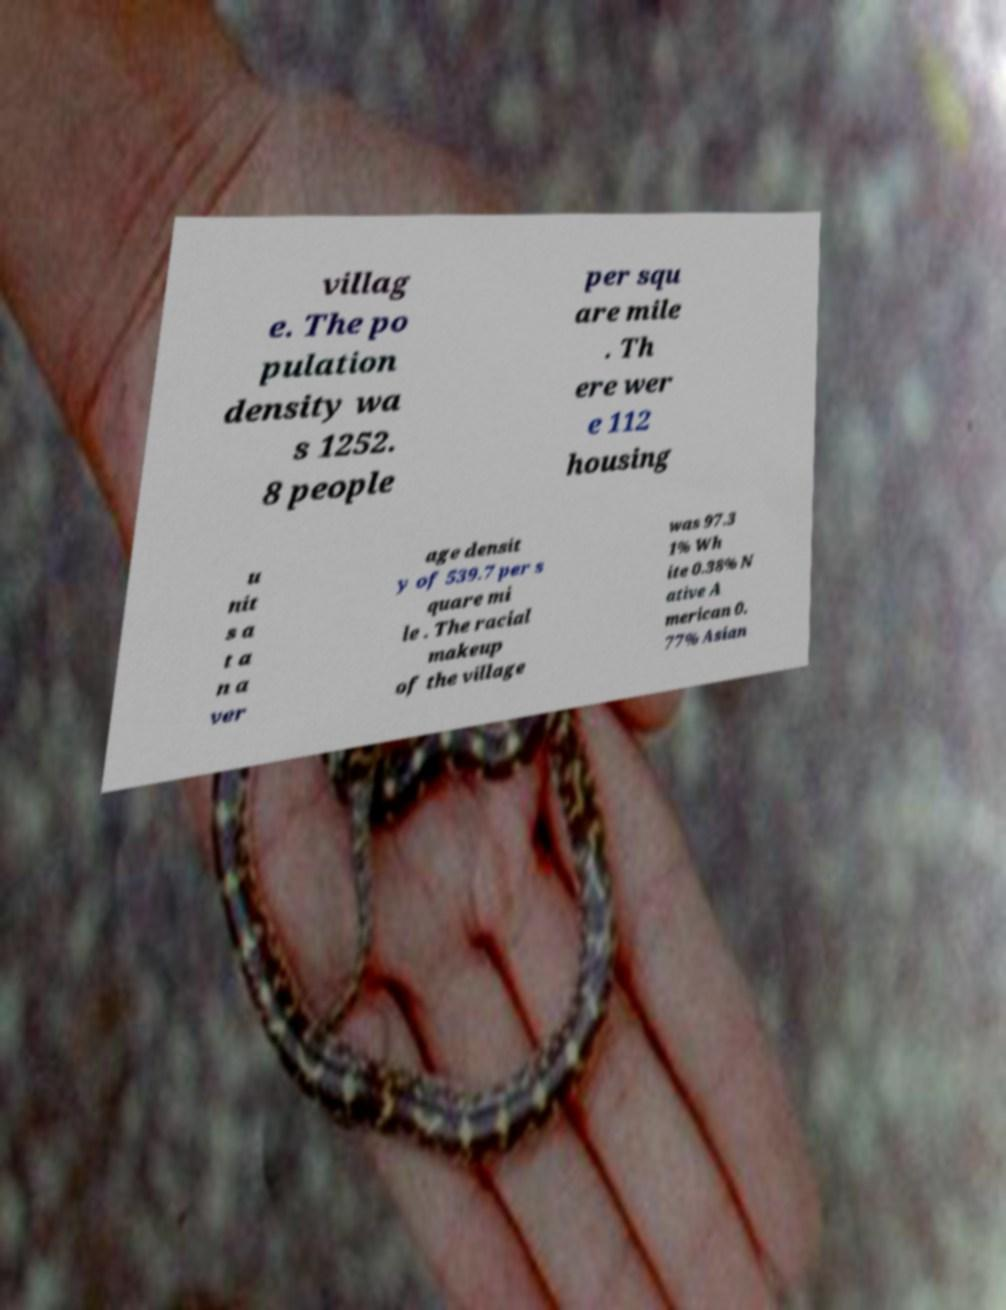Could you extract and type out the text from this image? villag e. The po pulation density wa s 1252. 8 people per squ are mile . Th ere wer e 112 housing u nit s a t a n a ver age densit y of 539.7 per s quare mi le . The racial makeup of the village was 97.3 1% Wh ite 0.38% N ative A merican 0. 77% Asian 